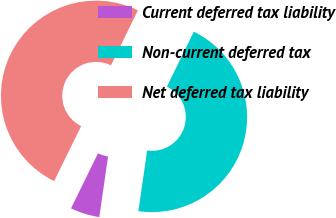<chart> <loc_0><loc_0><loc_500><loc_500><pie_chart><fcel>Current deferred tax liability<fcel>Non-current deferred tax<fcel>Net deferred tax liability<nl><fcel>4.97%<fcel>45.03%<fcel>50.0%<nl></chart> 